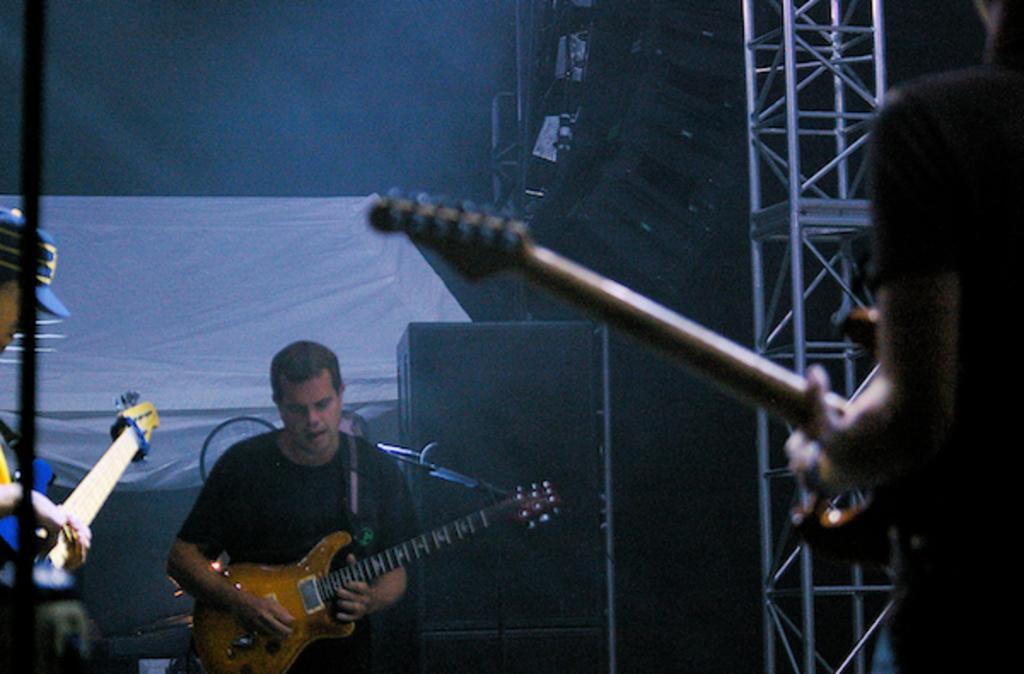Please provide a concise description of this image. three persons are playing guitar 